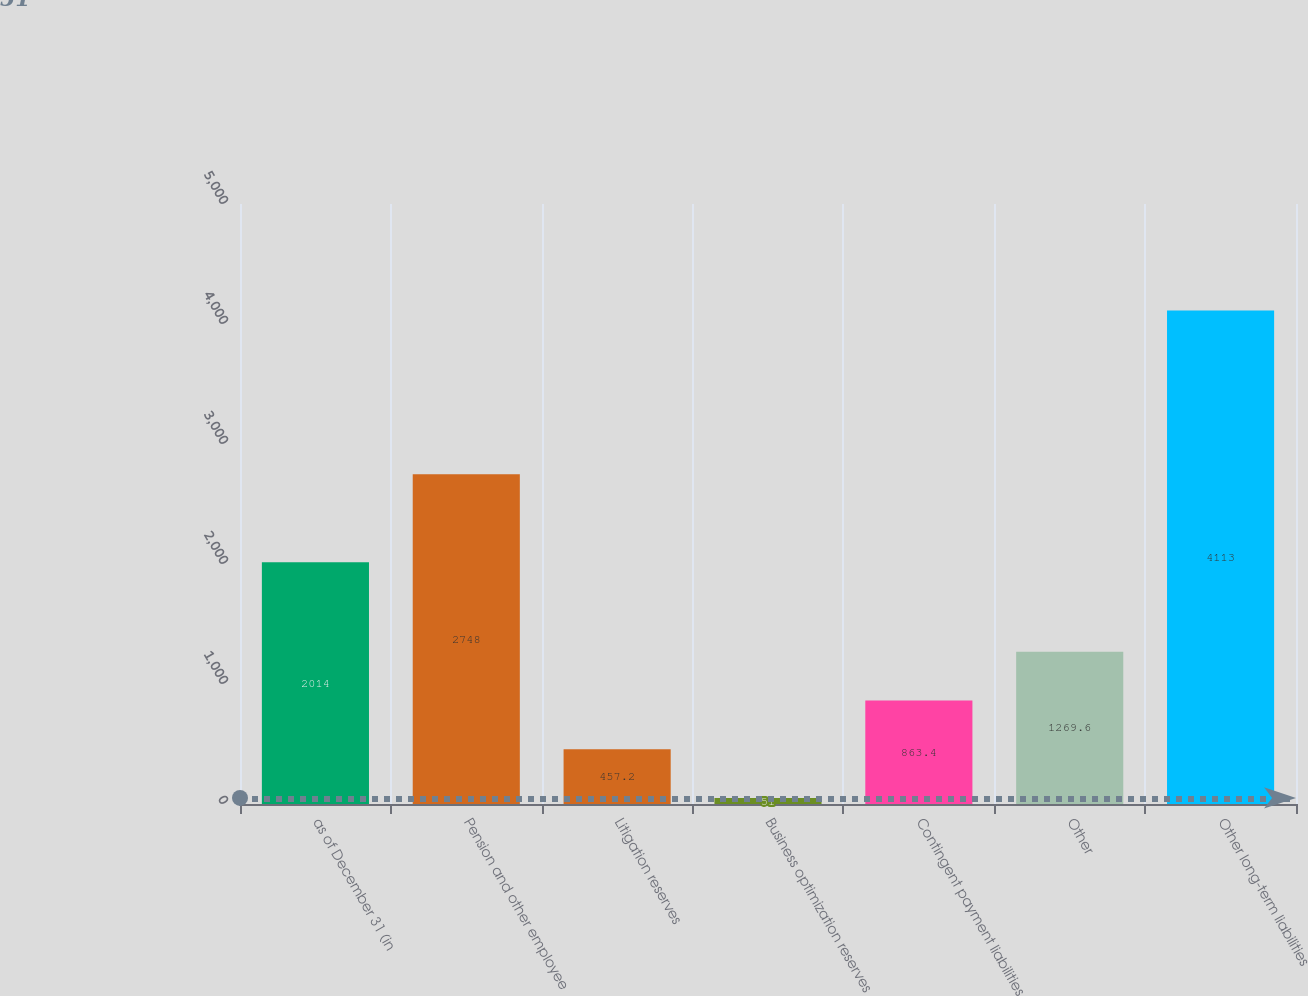Convert chart. <chart><loc_0><loc_0><loc_500><loc_500><bar_chart><fcel>as of December 31 (in<fcel>Pension and other employee<fcel>Litigation reserves<fcel>Business optimization reserves<fcel>Contingent payment liabilities<fcel>Other<fcel>Other long-term liabilities<nl><fcel>2014<fcel>2748<fcel>457.2<fcel>51<fcel>863.4<fcel>1269.6<fcel>4113<nl></chart> 